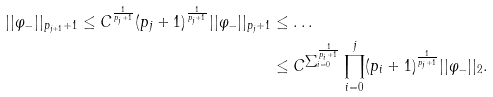Convert formula to latex. <formula><loc_0><loc_0><loc_500><loc_500>| | \varphi _ { - } | | _ { p _ { j + 1 } + 1 } \leq C ^ { \frac { 1 } { p _ { j } + 1 } } ( p _ { j } + 1 ) ^ { \frac { 1 } { p _ { j } + 1 } } | | \varphi _ { - } | | _ { p _ { j } + 1 } & \leq \dots \\ & \leq C ^ { \sum _ { i = 0 } ^ { \frac { 1 } { p _ { i } + 1 } } } \prod _ { i = 0 } ^ { j } ( p _ { i } + 1 ) ^ { \frac { 1 } { p _ { j } + 1 } } | | \varphi _ { - } | | _ { 2 } .</formula> 